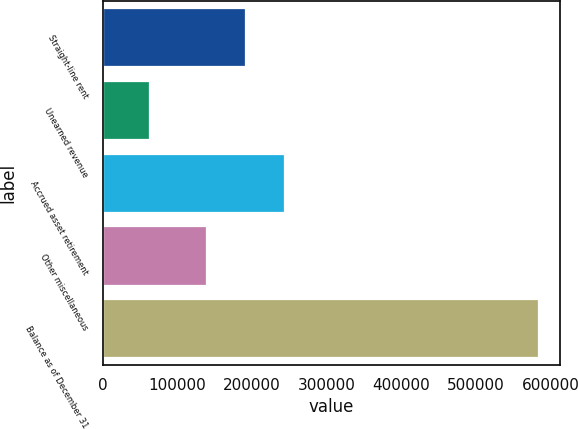Convert chart to OTSL. <chart><loc_0><loc_0><loc_500><loc_500><bar_chart><fcel>Straight-line rent<fcel>Unearned revenue<fcel>Accrued asset retirement<fcel>Other miscellaneous<fcel>Balance as of December 31<nl><fcel>190800<fcel>62893<fcel>242834<fcel>138766<fcel>583232<nl></chart> 